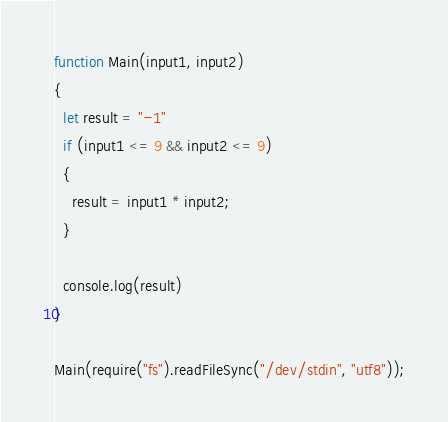<code> <loc_0><loc_0><loc_500><loc_500><_JavaScript_>function Main(input1, input2)
{
  let result = "-1"
  if (input1 <= 9 && input2 <= 9)
  {
    result = input1 * input2;
  }

  console.log(result)
}

Main(require("fs").readFileSync("/dev/stdin", "utf8"));</code> 